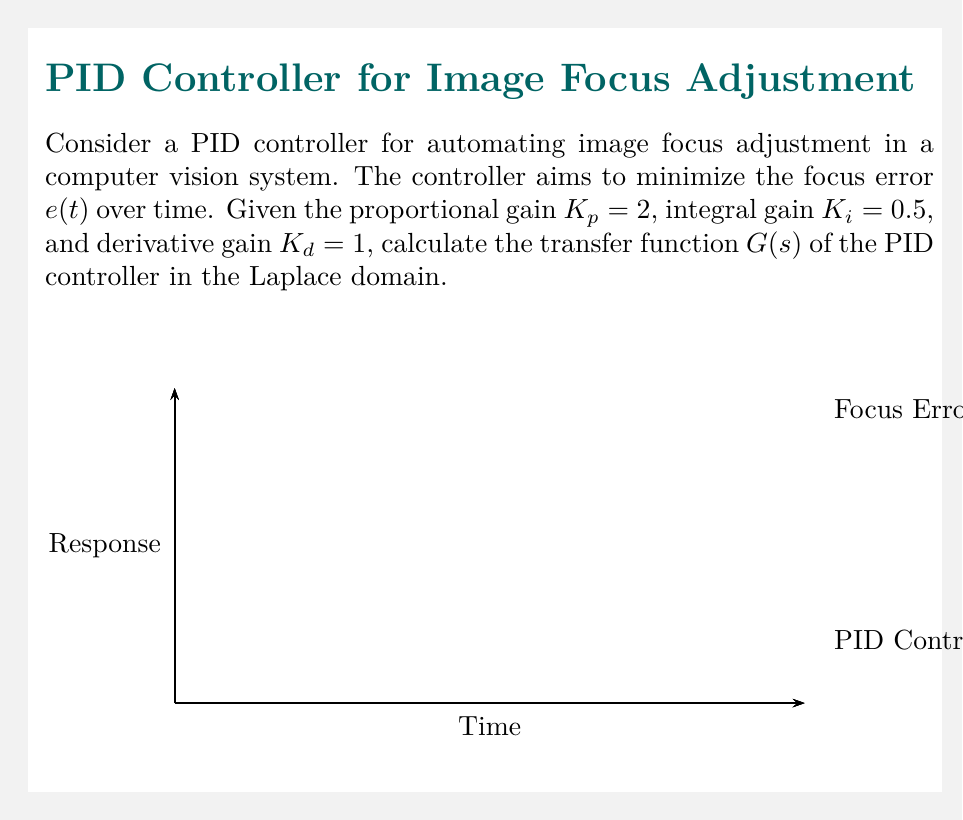Can you solve this math problem? To calculate the transfer function of the PID controller, we need to follow these steps:

1. Recall the general form of a PID controller in the time domain:

   $$u(t) = K_p e(t) + K_i \int_0^t e(\tau) d\tau + K_d \frac{de(t)}{dt}$$

2. Take the Laplace transform of the PID controller equation:

   $$U(s) = K_p E(s) + K_i \frac{E(s)}{s} + K_d s E(s)$$

3. Factor out $E(s)$ to isolate the transfer function:

   $$U(s) = E(s) \left(K_p + \frac{K_i}{s} + K_d s\right)$$

4. The transfer function $G(s)$ is defined as the ratio of output to input in the Laplace domain:

   $$G(s) = \frac{U(s)}{E(s)} = K_p + \frac{K_i}{s} + K_d s$$

5. Substitute the given values: $K_p = 2$, $K_i = 0.5$, and $K_d = 1$:

   $$G(s) = 2 + \frac{0.5}{s} + s$$

6. Find a common denominator to express the transfer function as a rational function:

   $$G(s) = \frac{2s^2 + 0.5 + s^3}{s}$$

This is the final form of the transfer function for the given PID controller.
Answer: $$G(s) = \frac{s^3 + 2s^2 + 0.5}{s}$$ 